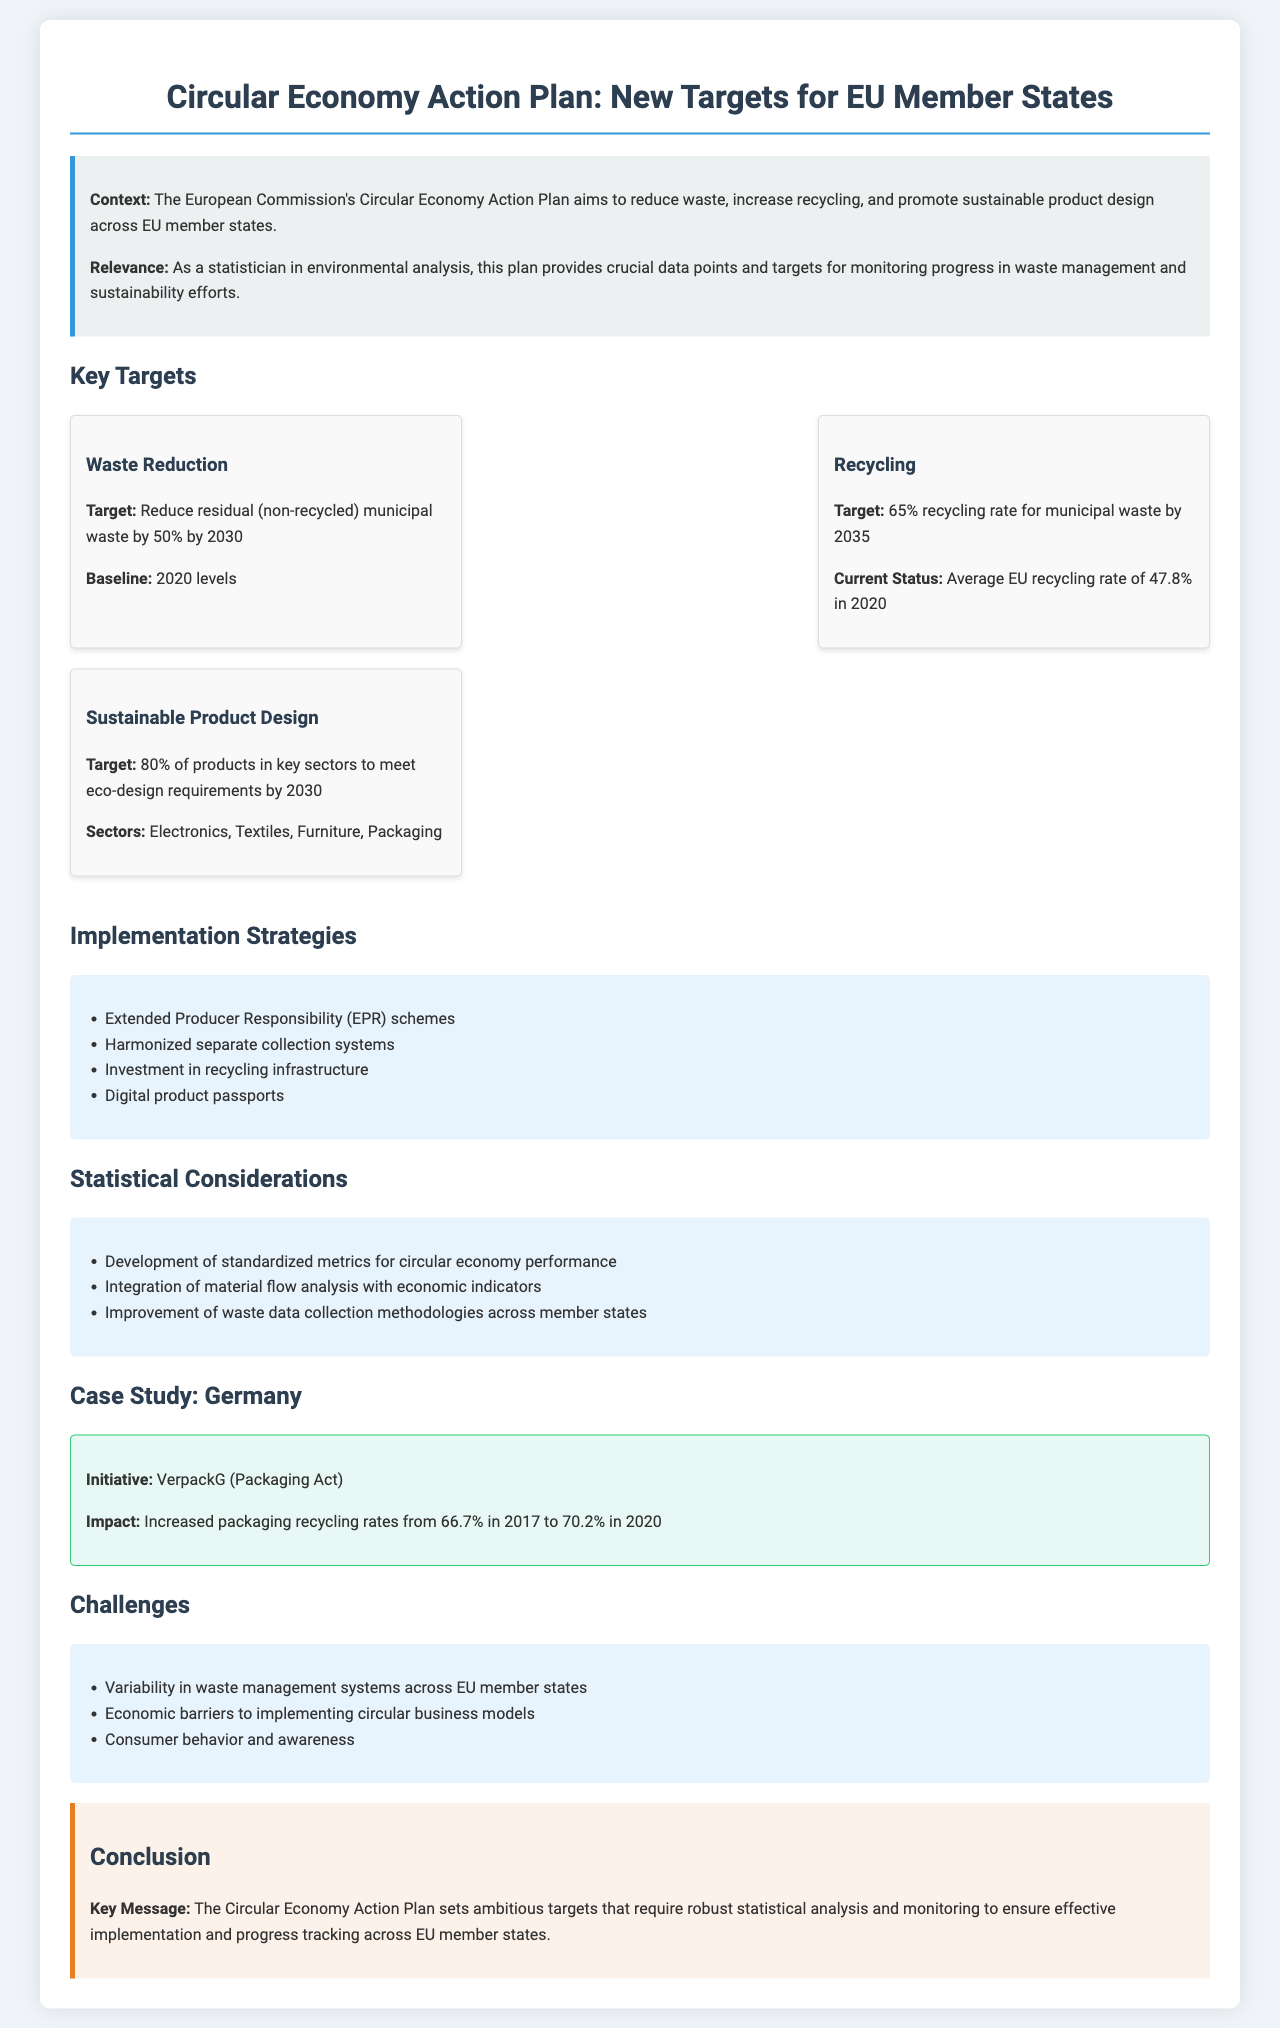What is the target for waste reduction by 2030? The document states that the target is to reduce residual (non-recycled) municipal waste by 50% by 2030.
Answer: 50% What is the average EU recycling rate in 2020? According to the document, the average EU recycling rate was 47.8% in 2020.
Answer: 47.8% What percentage of products in key sectors must meet eco-design requirements by 2030? The document indicates that 80% of products in key sectors should meet eco-design requirements by 2030.
Answer: 80% Which act is cited as a case study for Germany? The document mentions the VerpackG (Packaging Act) as the initiative in the case study.
Answer: VerpackG What are the economic barriers mentioned in the challenges section? The document states that economic barriers to implementing circular business models are a challenge.
Answer: Economic barriers What type of responsibilities do Extended Producer Responsibility (EPR) schemes signify? EPR schemes signify a strategy aimed at promoting waste reduction and recycling responsibilities among producers.
Answer: Waste reduction and recycling responsibilities What impact did the VerpackG have on packaging recycling rates from 2017 to 2020? The document highlights that it increased recycling rates from 66.7% in 2017 to 70.2% in 2020.
Answer: Increased from 66.7% to 70.2% What is one of the implementation strategies mentioned in the document? The document lists investment in recycling infrastructure as one of the implementation strategies.
Answer: Investment in recycling infrastructure 